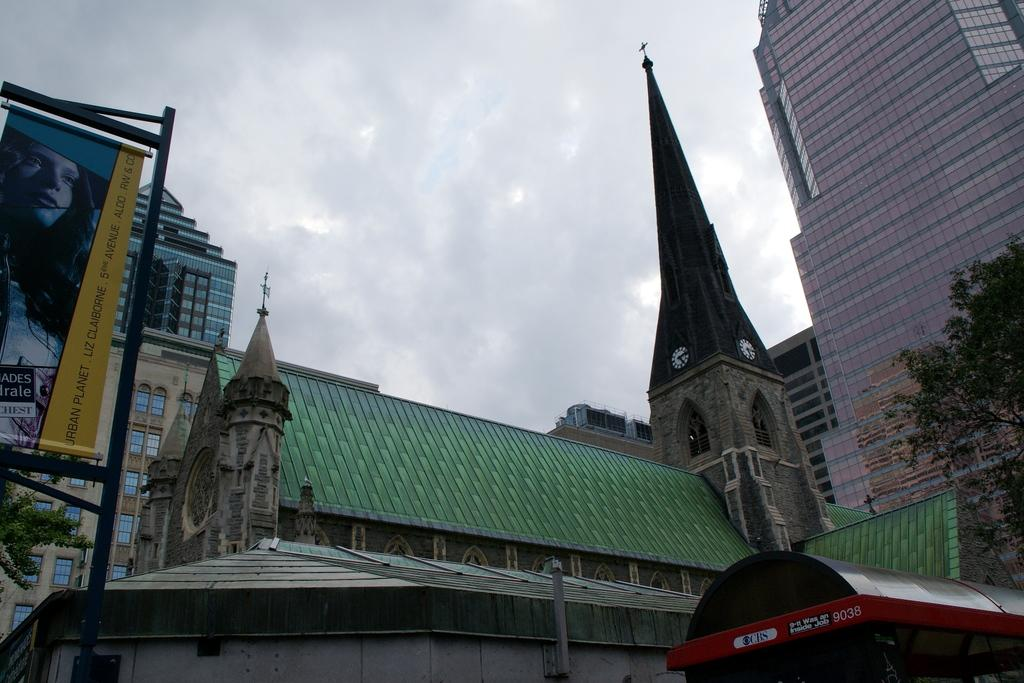What is hanging or displayed in the image? There is a banner in the image. What type of natural elements can be seen in the image? There are trees in the image. What type of structures are visible in the image? There are buildings with windows in the image. What can be seen in the background of the image? The sky is visible in the background of the image. What is the condition of the sky in the image? Clouds are present in the sky. What type of fruit is being eaten by the banner in the image? There is no fruit present in the image, and the banner is not capable of eating. 